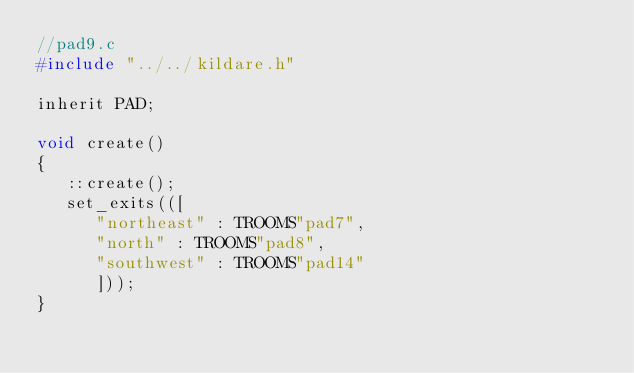Convert code to text. <code><loc_0><loc_0><loc_500><loc_500><_C_>//pad9.c
#include "../../kildare.h"

inherit PAD;

void create()
{
   ::create();
   set_exits(([
      "northeast" : TROOMS"pad7",
      "north" : TROOMS"pad8",
      "southwest" : TROOMS"pad14"
      ]));
}
</code> 